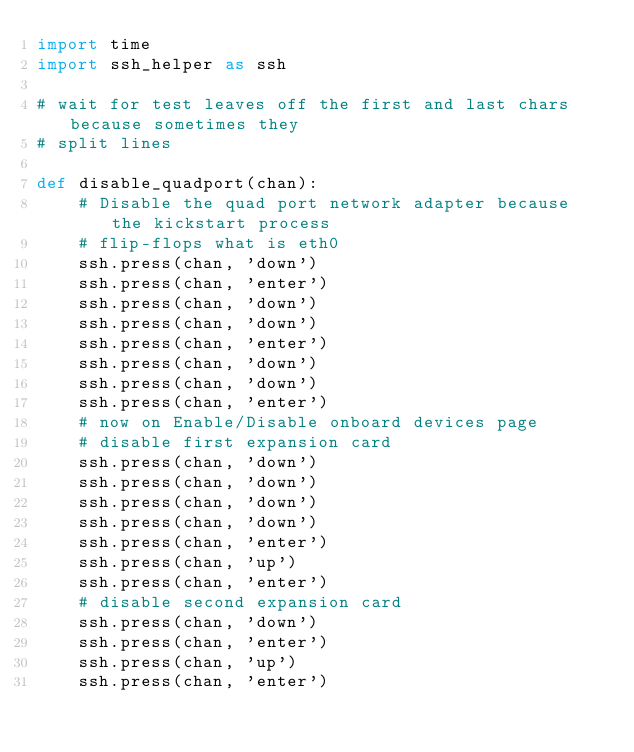<code> <loc_0><loc_0><loc_500><loc_500><_Python_>import time
import ssh_helper as ssh

# wait for test leaves off the first and last chars because sometimes they 
# split lines

def disable_quadport(chan):
    # Disable the quad port network adapter because the kickstart process 
    # flip-flops what is eth0
    ssh.press(chan, 'down')
    ssh.press(chan, 'enter')
    ssh.press(chan, 'down')
    ssh.press(chan, 'down')
    ssh.press(chan, 'enter')
    ssh.press(chan, 'down')
    ssh.press(chan, 'down')
    ssh.press(chan, 'enter')
    # now on Enable/Disable onboard devices page
    # disable first expansion card
    ssh.press(chan, 'down')
    ssh.press(chan, 'down')
    ssh.press(chan, 'down')
    ssh.press(chan, 'down')
    ssh.press(chan, 'enter')
    ssh.press(chan, 'up')
    ssh.press(chan, 'enter')
    # disable second expansion card
    ssh.press(chan, 'down')
    ssh.press(chan, 'enter')
    ssh.press(chan, 'up')
    ssh.press(chan, 'enter')</code> 